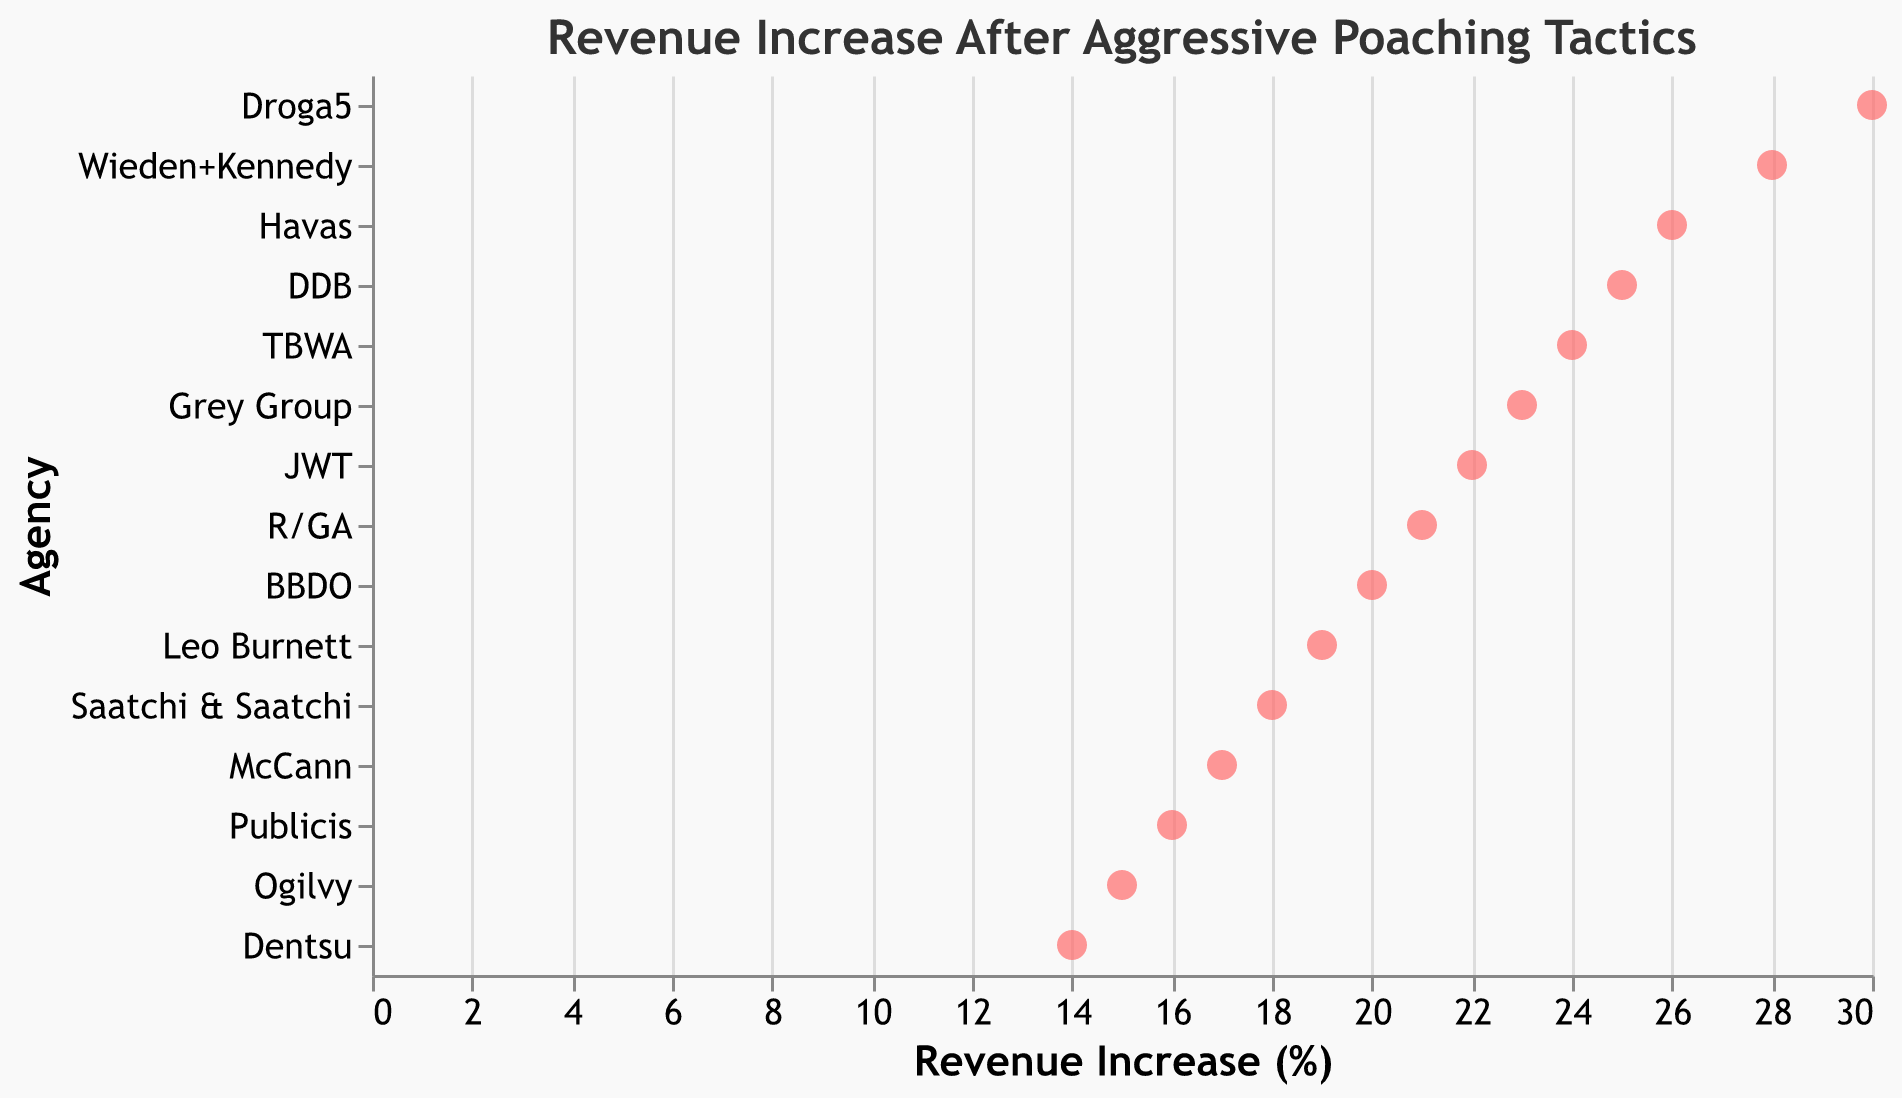What is the title of the plot? The title of the plot is shown at the top.
Answer: Revenue Increase After Aggressive Poaching Tactics How many agencies are displayed in the plot? The Y-axis lists the number of agencies, each represented by a data point. By counting the agencies on the Y-axis, we see there are 15 agencies.
Answer: 15 Which agency has the highest revenue increase percentage? By locating the highest point on the X-axis, we find Droga5 with a revenue increase percentage of 30%.
Answer: Droga5 What is the revenue increase percentage for Havas? The data point for Havas is located along the X-axis, showing a revenue increase percentage of 26%.
Answer: 26% Which agency has the lowest revenue increase percentage? By locating the lowest point on the X-axis, we find Dentsu with a revenue increase percentage of 14%.
Answer: Dentsu What is the average revenue increase percentage across all agencies? Sum the revenues (15+22+18+25+20+17+23+19+28+30+21+24+16+26+14) which equals 318, then divide by the number of agencies (15). The average is 318/15.
Answer: 21.2% How does the revenue increase percentage of McCann compare to that of JWT? By comparing the data points, McCann has 17%, and JWT has 22%. JWT's percentage is 5% higher than McCann's.
Answer: JWT by 5% Which three agencies have revenue increases between 25% and 30%? By identifying the points within this range, DDB (25%), Havas (26%), and Droga5 (30%) fall between 25% and 30%.
Answer: DDB, Havas, Droga5 